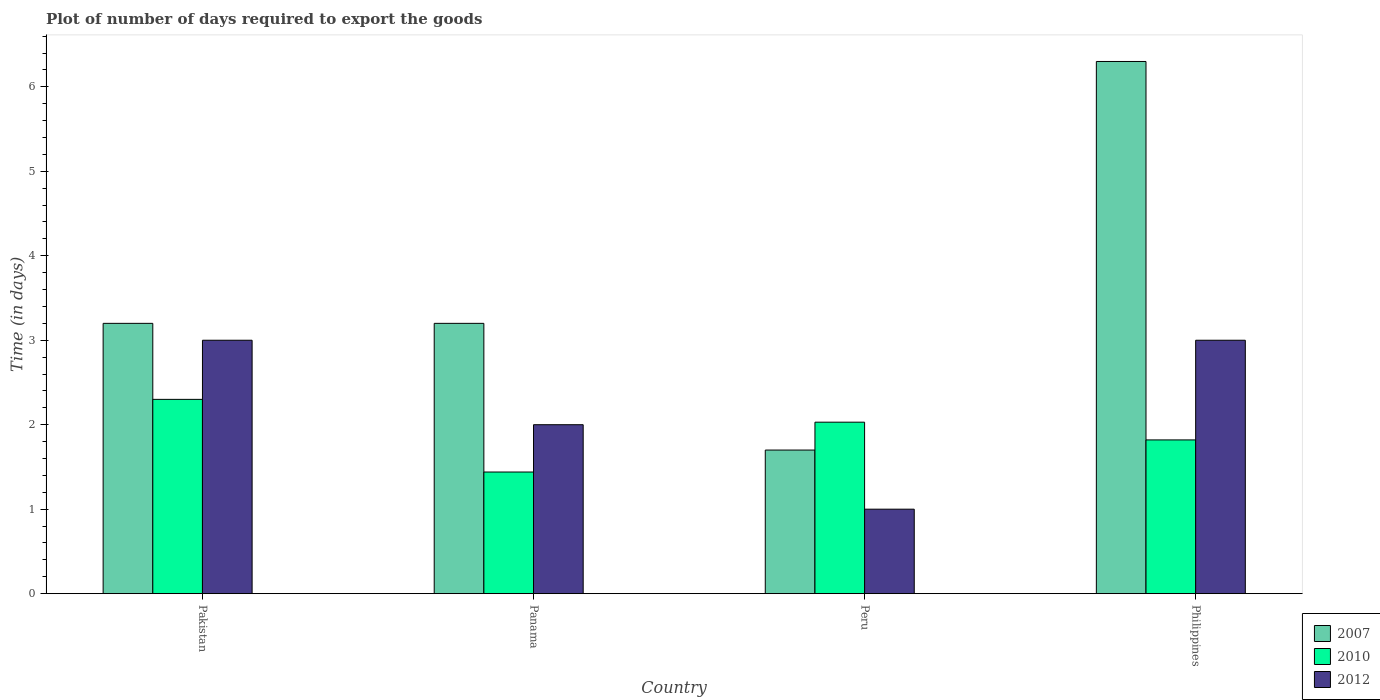How many groups of bars are there?
Offer a very short reply. 4. Are the number of bars per tick equal to the number of legend labels?
Make the answer very short. Yes. Are the number of bars on each tick of the X-axis equal?
Make the answer very short. Yes. In how many cases, is the number of bars for a given country not equal to the number of legend labels?
Keep it short and to the point. 0. What is the time required to export goods in 2012 in Panama?
Provide a succinct answer. 2. Across all countries, what is the maximum time required to export goods in 2007?
Keep it short and to the point. 6.3. In which country was the time required to export goods in 2007 minimum?
Your response must be concise. Peru. What is the total time required to export goods in 2010 in the graph?
Offer a very short reply. 7.59. What is the difference between the time required to export goods in 2010 in Pakistan and that in Peru?
Offer a very short reply. 0.27. What is the difference between the time required to export goods in 2007 in Peru and the time required to export goods in 2010 in Philippines?
Provide a short and direct response. -0.12. What is the average time required to export goods in 2012 per country?
Your response must be concise. 2.25. What is the difference between the time required to export goods of/in 2010 and time required to export goods of/in 2012 in Peru?
Your answer should be compact. 1.03. In how many countries, is the time required to export goods in 2007 greater than 6 days?
Keep it short and to the point. 1. What is the ratio of the time required to export goods in 2007 in Panama to that in Philippines?
Make the answer very short. 0.51. Is the difference between the time required to export goods in 2010 in Pakistan and Panama greater than the difference between the time required to export goods in 2012 in Pakistan and Panama?
Give a very brief answer. No. What is the difference between the highest and the second highest time required to export goods in 2007?
Your answer should be very brief. -3.1. What does the 2nd bar from the left in Pakistan represents?
Your response must be concise. 2010. Is it the case that in every country, the sum of the time required to export goods in 2012 and time required to export goods in 2007 is greater than the time required to export goods in 2010?
Offer a very short reply. Yes. How many countries are there in the graph?
Offer a very short reply. 4. What is the difference between two consecutive major ticks on the Y-axis?
Ensure brevity in your answer.  1. Are the values on the major ticks of Y-axis written in scientific E-notation?
Keep it short and to the point. No. Does the graph contain any zero values?
Keep it short and to the point. No. Where does the legend appear in the graph?
Give a very brief answer. Bottom right. How are the legend labels stacked?
Keep it short and to the point. Vertical. What is the title of the graph?
Your response must be concise. Plot of number of days required to export the goods. What is the label or title of the Y-axis?
Keep it short and to the point. Time (in days). What is the Time (in days) in 2007 in Panama?
Give a very brief answer. 3.2. What is the Time (in days) of 2010 in Panama?
Make the answer very short. 1.44. What is the Time (in days) of 2012 in Panama?
Provide a succinct answer. 2. What is the Time (in days) in 2007 in Peru?
Your answer should be very brief. 1.7. What is the Time (in days) in 2010 in Peru?
Your answer should be compact. 2.03. What is the Time (in days) in 2007 in Philippines?
Your answer should be compact. 6.3. What is the Time (in days) of 2010 in Philippines?
Offer a very short reply. 1.82. What is the Time (in days) of 2012 in Philippines?
Keep it short and to the point. 3. Across all countries, what is the maximum Time (in days) in 2007?
Provide a succinct answer. 6.3. Across all countries, what is the maximum Time (in days) of 2012?
Your response must be concise. 3. Across all countries, what is the minimum Time (in days) in 2007?
Keep it short and to the point. 1.7. Across all countries, what is the minimum Time (in days) of 2010?
Ensure brevity in your answer.  1.44. Across all countries, what is the minimum Time (in days) in 2012?
Provide a succinct answer. 1. What is the total Time (in days) of 2007 in the graph?
Ensure brevity in your answer.  14.4. What is the total Time (in days) of 2010 in the graph?
Your answer should be very brief. 7.59. What is the total Time (in days) in 2012 in the graph?
Provide a succinct answer. 9. What is the difference between the Time (in days) of 2010 in Pakistan and that in Panama?
Ensure brevity in your answer.  0.86. What is the difference between the Time (in days) in 2010 in Pakistan and that in Peru?
Your answer should be compact. 0.27. What is the difference between the Time (in days) of 2012 in Pakistan and that in Peru?
Your answer should be compact. 2. What is the difference between the Time (in days) in 2010 in Pakistan and that in Philippines?
Your answer should be compact. 0.48. What is the difference between the Time (in days) in 2010 in Panama and that in Peru?
Offer a very short reply. -0.59. What is the difference between the Time (in days) in 2010 in Panama and that in Philippines?
Provide a short and direct response. -0.38. What is the difference between the Time (in days) of 2007 in Peru and that in Philippines?
Offer a very short reply. -4.6. What is the difference between the Time (in days) of 2010 in Peru and that in Philippines?
Your answer should be compact. 0.21. What is the difference between the Time (in days) in 2007 in Pakistan and the Time (in days) in 2010 in Panama?
Keep it short and to the point. 1.76. What is the difference between the Time (in days) of 2007 in Pakistan and the Time (in days) of 2010 in Peru?
Keep it short and to the point. 1.17. What is the difference between the Time (in days) of 2007 in Pakistan and the Time (in days) of 2010 in Philippines?
Your answer should be very brief. 1.38. What is the difference between the Time (in days) of 2007 in Pakistan and the Time (in days) of 2012 in Philippines?
Your response must be concise. 0.2. What is the difference between the Time (in days) in 2007 in Panama and the Time (in days) in 2010 in Peru?
Provide a short and direct response. 1.17. What is the difference between the Time (in days) in 2007 in Panama and the Time (in days) in 2012 in Peru?
Keep it short and to the point. 2.2. What is the difference between the Time (in days) in 2010 in Panama and the Time (in days) in 2012 in Peru?
Give a very brief answer. 0.44. What is the difference between the Time (in days) in 2007 in Panama and the Time (in days) in 2010 in Philippines?
Provide a succinct answer. 1.38. What is the difference between the Time (in days) in 2007 in Panama and the Time (in days) in 2012 in Philippines?
Your answer should be very brief. 0.2. What is the difference between the Time (in days) of 2010 in Panama and the Time (in days) of 2012 in Philippines?
Provide a succinct answer. -1.56. What is the difference between the Time (in days) of 2007 in Peru and the Time (in days) of 2010 in Philippines?
Offer a terse response. -0.12. What is the difference between the Time (in days) in 2010 in Peru and the Time (in days) in 2012 in Philippines?
Your response must be concise. -0.97. What is the average Time (in days) of 2007 per country?
Provide a short and direct response. 3.6. What is the average Time (in days) of 2010 per country?
Ensure brevity in your answer.  1.9. What is the average Time (in days) of 2012 per country?
Offer a very short reply. 2.25. What is the difference between the Time (in days) in 2007 and Time (in days) in 2010 in Pakistan?
Your answer should be very brief. 0.9. What is the difference between the Time (in days) of 2007 and Time (in days) of 2010 in Panama?
Your answer should be compact. 1.76. What is the difference between the Time (in days) in 2007 and Time (in days) in 2012 in Panama?
Your answer should be very brief. 1.2. What is the difference between the Time (in days) of 2010 and Time (in days) of 2012 in Panama?
Your answer should be compact. -0.56. What is the difference between the Time (in days) of 2007 and Time (in days) of 2010 in Peru?
Your answer should be compact. -0.33. What is the difference between the Time (in days) in 2007 and Time (in days) in 2012 in Peru?
Provide a succinct answer. 0.7. What is the difference between the Time (in days) in 2007 and Time (in days) in 2010 in Philippines?
Offer a terse response. 4.48. What is the difference between the Time (in days) in 2007 and Time (in days) in 2012 in Philippines?
Offer a terse response. 3.3. What is the difference between the Time (in days) of 2010 and Time (in days) of 2012 in Philippines?
Give a very brief answer. -1.18. What is the ratio of the Time (in days) in 2007 in Pakistan to that in Panama?
Offer a very short reply. 1. What is the ratio of the Time (in days) of 2010 in Pakistan to that in Panama?
Your answer should be compact. 1.6. What is the ratio of the Time (in days) in 2007 in Pakistan to that in Peru?
Make the answer very short. 1.88. What is the ratio of the Time (in days) in 2010 in Pakistan to that in Peru?
Keep it short and to the point. 1.13. What is the ratio of the Time (in days) in 2012 in Pakistan to that in Peru?
Keep it short and to the point. 3. What is the ratio of the Time (in days) in 2007 in Pakistan to that in Philippines?
Provide a short and direct response. 0.51. What is the ratio of the Time (in days) of 2010 in Pakistan to that in Philippines?
Offer a very short reply. 1.26. What is the ratio of the Time (in days) in 2007 in Panama to that in Peru?
Keep it short and to the point. 1.88. What is the ratio of the Time (in days) in 2010 in Panama to that in Peru?
Keep it short and to the point. 0.71. What is the ratio of the Time (in days) of 2007 in Panama to that in Philippines?
Your answer should be very brief. 0.51. What is the ratio of the Time (in days) in 2010 in Panama to that in Philippines?
Provide a succinct answer. 0.79. What is the ratio of the Time (in days) in 2007 in Peru to that in Philippines?
Provide a succinct answer. 0.27. What is the ratio of the Time (in days) in 2010 in Peru to that in Philippines?
Your answer should be compact. 1.12. What is the difference between the highest and the second highest Time (in days) of 2007?
Your answer should be very brief. 3.1. What is the difference between the highest and the second highest Time (in days) of 2010?
Give a very brief answer. 0.27. What is the difference between the highest and the second highest Time (in days) in 2012?
Provide a short and direct response. 0. What is the difference between the highest and the lowest Time (in days) of 2007?
Offer a very short reply. 4.6. What is the difference between the highest and the lowest Time (in days) in 2010?
Provide a succinct answer. 0.86. What is the difference between the highest and the lowest Time (in days) of 2012?
Give a very brief answer. 2. 